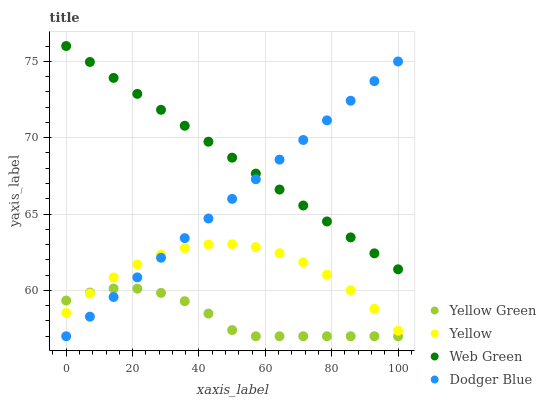Does Yellow Green have the minimum area under the curve?
Answer yes or no. Yes. Does Web Green have the maximum area under the curve?
Answer yes or no. Yes. Does Dodger Blue have the minimum area under the curve?
Answer yes or no. No. Does Dodger Blue have the maximum area under the curve?
Answer yes or no. No. Is Dodger Blue the smoothest?
Answer yes or no. Yes. Is Yellow the roughest?
Answer yes or no. Yes. Is Yellow Green the smoothest?
Answer yes or no. No. Is Yellow Green the roughest?
Answer yes or no. No. Does Dodger Blue have the lowest value?
Answer yes or no. Yes. Does Yellow have the lowest value?
Answer yes or no. No. Does Web Green have the highest value?
Answer yes or no. Yes. Does Dodger Blue have the highest value?
Answer yes or no. No. Is Yellow Green less than Web Green?
Answer yes or no. Yes. Is Web Green greater than Yellow?
Answer yes or no. Yes. Does Dodger Blue intersect Yellow?
Answer yes or no. Yes. Is Dodger Blue less than Yellow?
Answer yes or no. No. Is Dodger Blue greater than Yellow?
Answer yes or no. No. Does Yellow Green intersect Web Green?
Answer yes or no. No. 